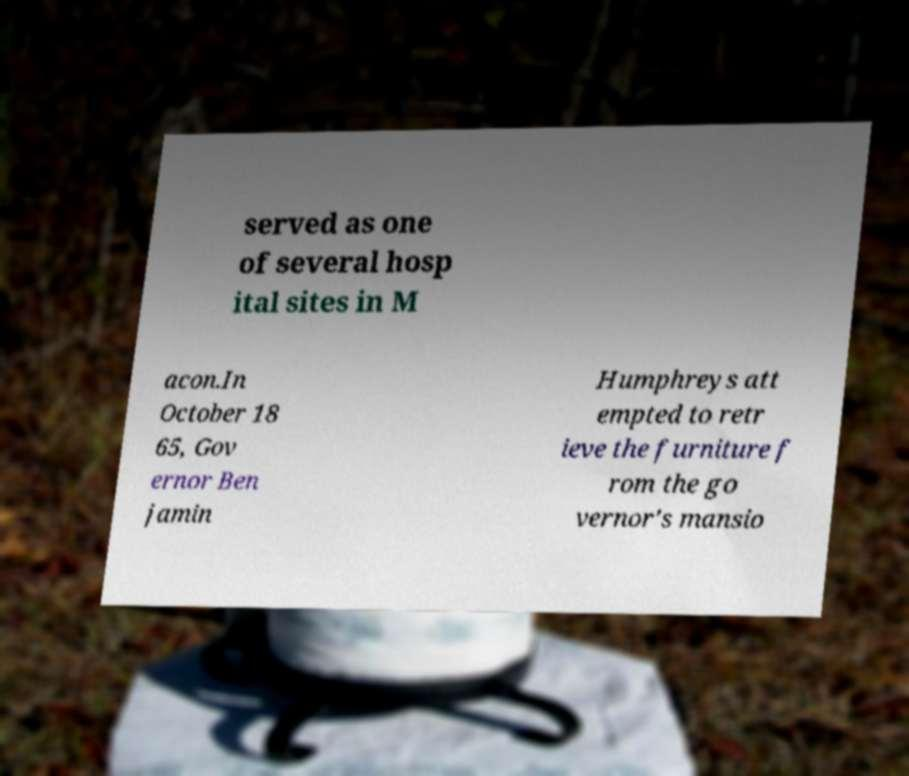Please identify and transcribe the text found in this image. served as one of several hosp ital sites in M acon.In October 18 65, Gov ernor Ben jamin Humphreys att empted to retr ieve the furniture f rom the go vernor's mansio 